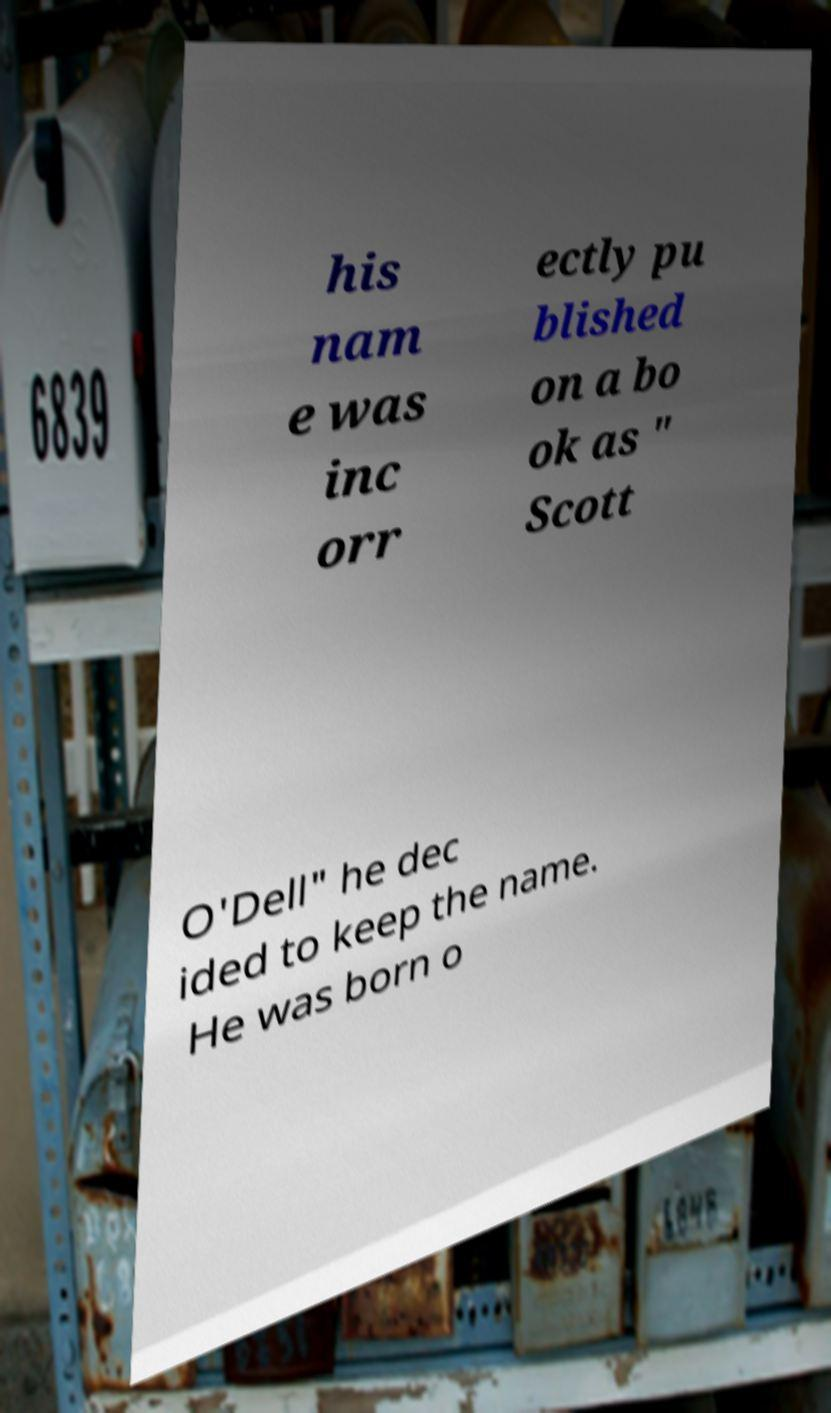Please identify and transcribe the text found in this image. his nam e was inc orr ectly pu blished on a bo ok as " Scott O'Dell" he dec ided to keep the name. He was born o 